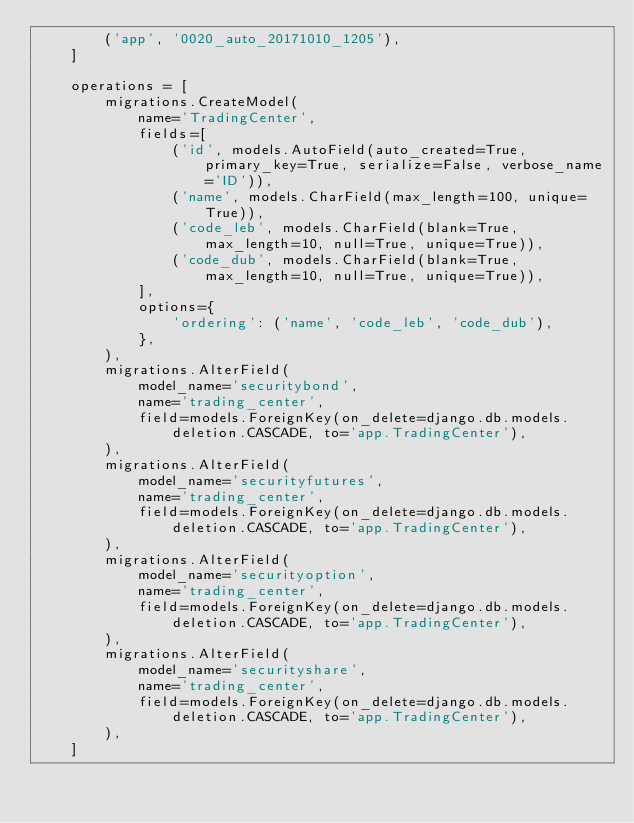<code> <loc_0><loc_0><loc_500><loc_500><_Python_>        ('app', '0020_auto_20171010_1205'),
    ]

    operations = [
        migrations.CreateModel(
            name='TradingCenter',
            fields=[
                ('id', models.AutoField(auto_created=True, primary_key=True, serialize=False, verbose_name='ID')),
                ('name', models.CharField(max_length=100, unique=True)),
                ('code_leb', models.CharField(blank=True, max_length=10, null=True, unique=True)),
                ('code_dub', models.CharField(blank=True, max_length=10, null=True, unique=True)),
            ],
            options={
                'ordering': ('name', 'code_leb', 'code_dub'),
            },
        ),
        migrations.AlterField(
            model_name='securitybond',
            name='trading_center',
            field=models.ForeignKey(on_delete=django.db.models.deletion.CASCADE, to='app.TradingCenter'),
        ),
        migrations.AlterField(
            model_name='securityfutures',
            name='trading_center',
            field=models.ForeignKey(on_delete=django.db.models.deletion.CASCADE, to='app.TradingCenter'),
        ),
        migrations.AlterField(
            model_name='securityoption',
            name='trading_center',
            field=models.ForeignKey(on_delete=django.db.models.deletion.CASCADE, to='app.TradingCenter'),
        ),
        migrations.AlterField(
            model_name='securityshare',
            name='trading_center',
            field=models.ForeignKey(on_delete=django.db.models.deletion.CASCADE, to='app.TradingCenter'),
        ),
    ]
</code> 